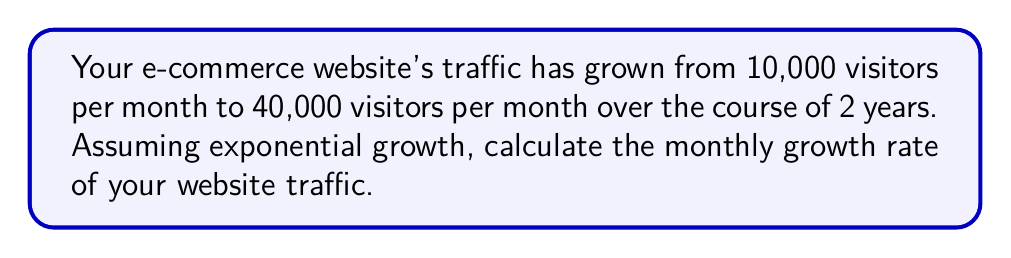Can you solve this math problem? Let's approach this step-by-step:

1) The exponential growth formula is:

   $$A = P(1 + r)^t$$

   Where:
   A = Final amount
   P = Initial amount
   r = Growth rate (as a decimal)
   t = Time period

2) We know:
   P = 10,000 (initial visitors)
   A = 40,000 (final visitors)
   t = 24 (months)

3) Plugging these into our formula:

   $$40,000 = 10,000(1 + r)^{24}$$

4) Divide both sides by 10,000:

   $$4 = (1 + r)^{24}$$

5) Take the 24th root of both sides:

   $$\sqrt[24]{4} = 1 + r$$

6) Subtract 1 from both sides:

   $$\sqrt[24]{4} - 1 = r$$

7) Calculate:

   $$r \approx 1.0573 - 1 = 0.0573$$

8) Convert to a percentage:

   $$0.0573 \times 100 = 5.73\%$$
Answer: 5.73% 